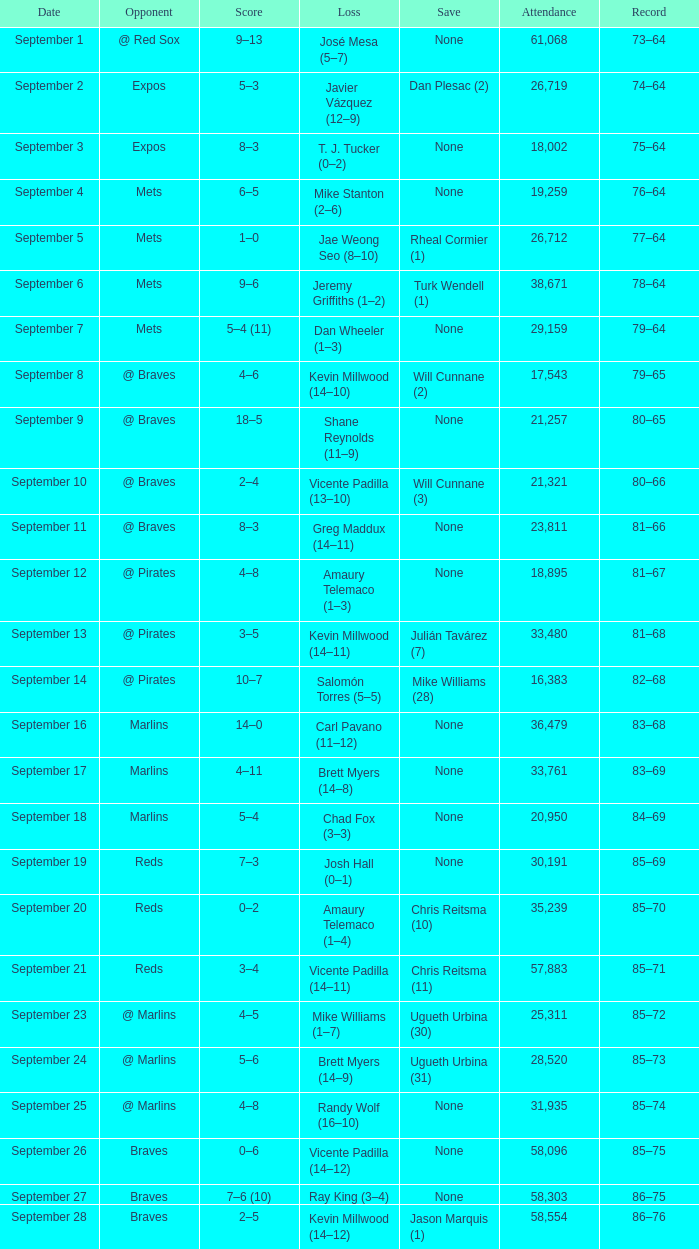What was the score of the game that had a loss of Chad Fox (3–3)? 5–4. 